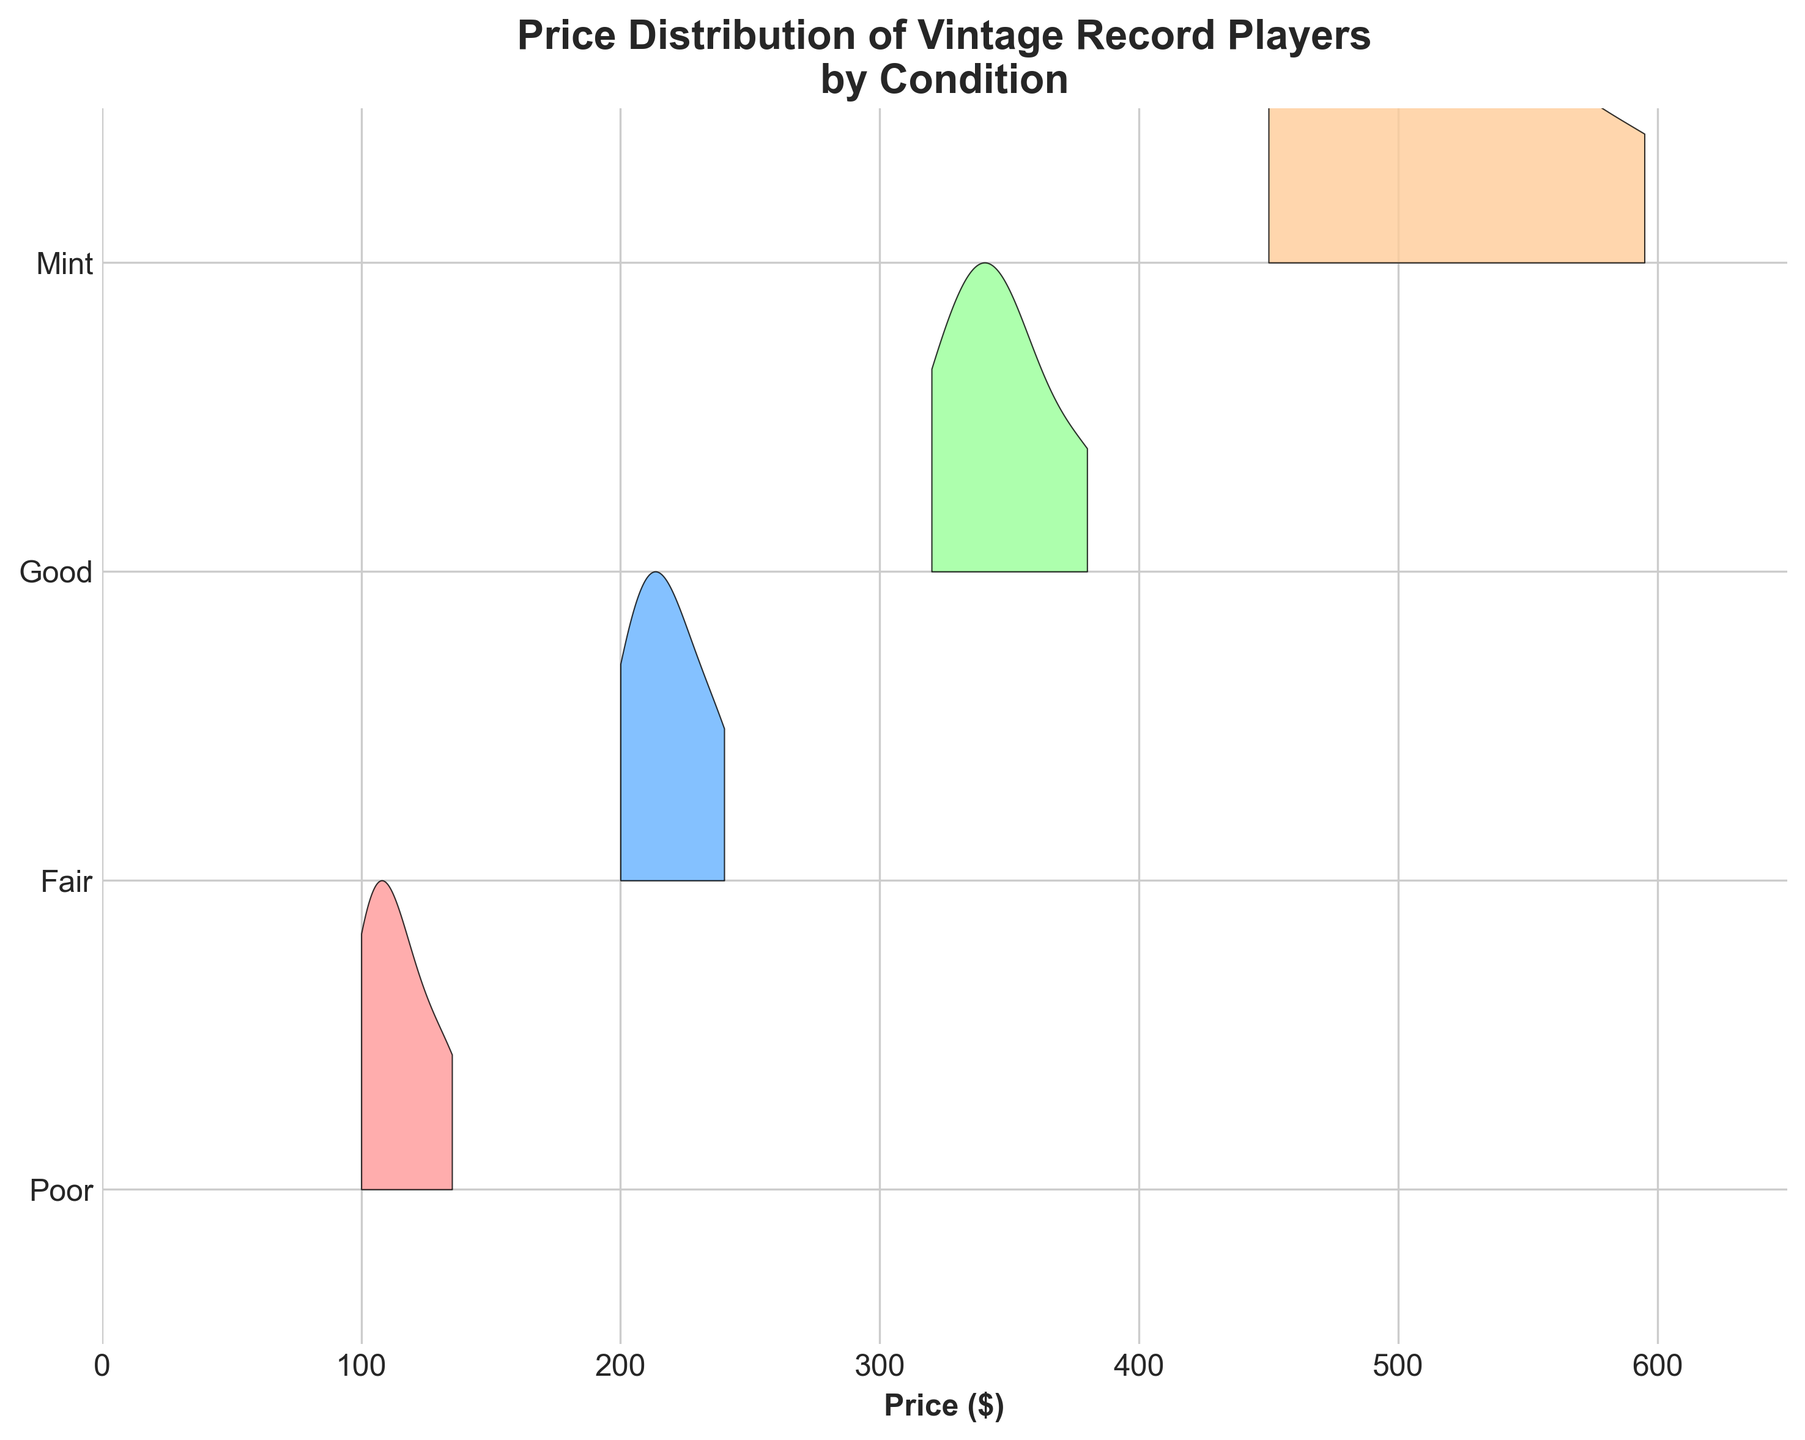What is the title of the figure? The title is typically located at the top of the figure and often provides a summary of the content or main takeaway. In this case, the title is "Price Distribution of Vintage Record Players by Condition"
Answer: Price Distribution of Vintage Record Players by Condition What are the conditions being compared in the plot? Conditions are listed on the y-axis, representing different groupings for the data. The conditions being compared are 'Poor', 'Fair', 'Good', and 'Mint'.
Answer: Poor, Fair, Good, Mint Which condition has the highest price range? Look at the x-axis, which shows the price range, and compare the coverage for each condition. The condition 'Mint' extends the farthest on the x-axis, indicating the highest price range.
Answer: Mint What price range is covered by the condition 'Fair'? By looking at where the 'Fair' condition spans along the x-axis, we can see that it covers approximately from $200 to $240.
Answer: $200 to $240 Which color represents the 'Mint' condition? By matching the color of the 'Mint' condition with the information provided, 'Mint' is represented by a light orange shade.
Answer: Light orange Which condition has the narrowest price distribution? The condition with the smallest spread along the x-axis represents the narrowest price distribution. 'Poor' condition spans the shortest distance from $100 to $135.
Answer: Poor How does the price range of 'Good' compare to 'Fair'? To compare, look at the price span on the x-axis: 'Good' ranges from $320 to $380, while 'Fair' ranges from $200 to $240. 'Good' has a higher and wider range.
Answer: Good has a higher and wider range Which condition has the most symmetric distribution shape? The symmetry can be observed by noticing the even spread of the curve around the peak. The 'Mint' condition curve appears most symmetric.
Answer: Mint What is the lowest price observed across all conditions? The lowest price can be identified by looking at the leftmost point on the x-axis. The lowest observed price is $100 under the 'Poor' category.
Answer: $100 What is the greatest price observed across all conditions? The greatest price can be identified by looking at the rightmost point on the x-axis. The highest observed price is $595 under the 'Mint' category.
Answer: $595 Which condition has the peak density at the closest point to $300? By analyzing the curves and their peak points along the x-axis, 'Good' condition peaks closest around $320.
Answer: Good 